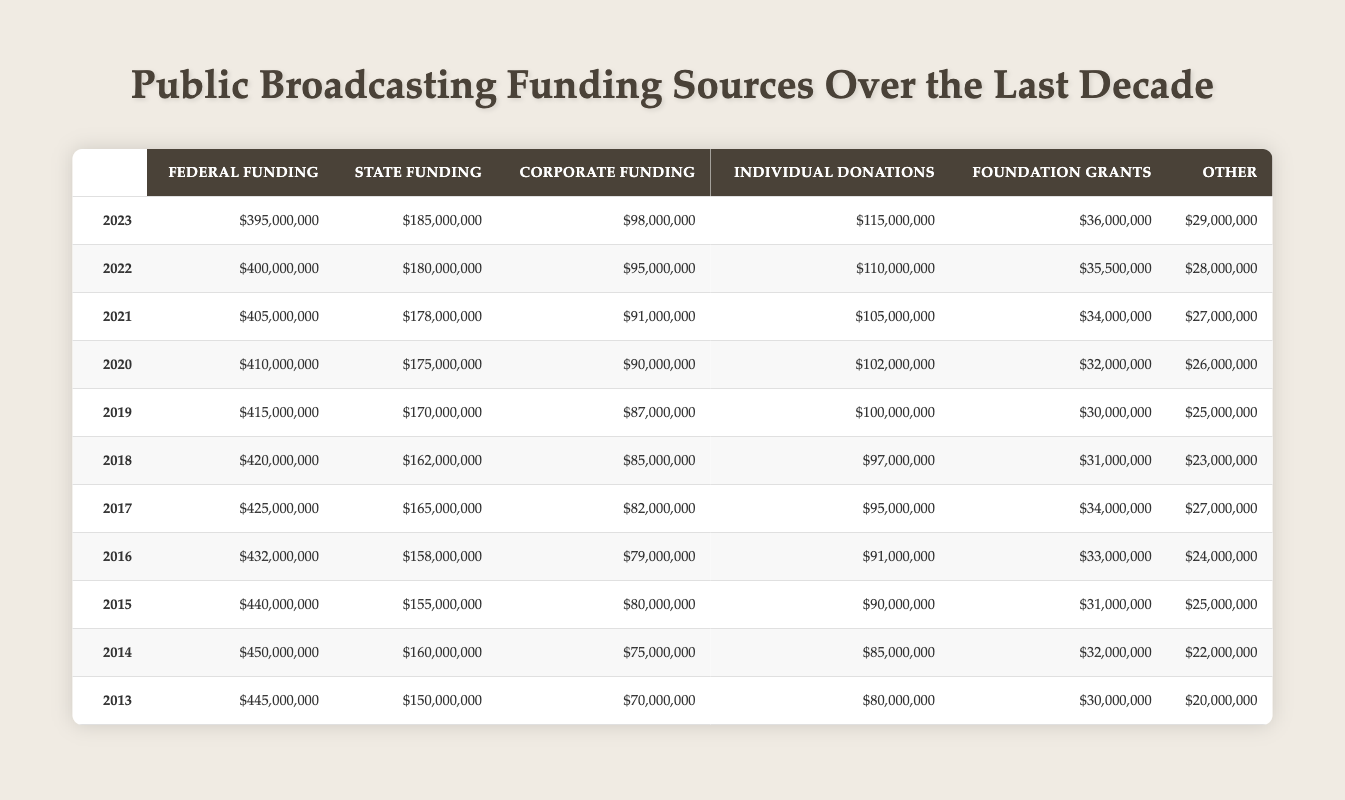What was the total Federal Funding in 2020? The table shows the Federal Funding value for 2020 as $410,000,000.
Answer: $410,000,000 Which year had the highest Individual Donations? The highest value for Individual Donations is in 2023, which is $115,000,000. We can see this value in the 2023 row of the table.
Answer: $115,000,000 In which year did State Funding first exceed $180 million? Looking at the table, State Funding first exceeded $180 million in 2022, which is evident because the value in that year is $180,000,000.
Answer: 2022 What was the increase in Foundation Grants from 2013 to 2023? Foundation Grants in 2013 were $30,000,000, and in 2023 they were $36,000,000. The increase is calculated as $36,000,000 - $30,000,000 = $6,000,000.
Answer: $6,000,000 What was the total Corporate Funding across all years in the table? To find the total Corporate Funding, we sum the Corporate Funding values from all years: $70,000,000 + $75,000,000 + $80,000,000 + $79,000,000 + $82,000,000 + $85,000,000 + $87,000,000 + $90,000,000 + $91,000,000 + $95,000,000 + $98,000,000 = $1,022,000,000.
Answer: $1,022,000,000 Did Federal Funding decrease every year from 2013 to 2023? Checking the values for Federal Funding each year, we can see a consistent decline from $445,000,000 in 2013 to $395,000,000 in 2023, confirming that it decreased every year.
Answer: Yes Which funding source had the most significant increase from 2013 to 2023? Comparing the values, Individual Donations increased from $80,000,000 in 2013 to $115,000,000 in 2023, an increase of $35,000,000. Meanwhile, the next highest increase was Foundation Grants, which went from $30,000,000 to $36,000,000 ($6,000,000). Thus, Individual Donations had the most significant increase.
Answer: Individual Donations What was the average amount of Other funding from 2013 to 2023? To find the average of Other funding, we first sum the values: $20,000,000 + $22,000,000 + $25,000,000 + $24,000,000 + $27,000,000 + $23,000,000 + $25,000,000 + $26,000,000 + $28,000,000 + $29,000,000 = $ 9 1,000,000. Then we divide by the number of years (11). The average is $260,000,000 / 11 = approximately $25,454,545.
Answer: Approximately $25,454,545 What percentage of funding in 2021 came from Federal sources? In 2021, Federal Funding was $405,000,000, and total funding for that year (summing all sources) was $405,000,000 + $178,000,000 + $91,000,000 + $105,000,000 + $34,000,000 + $27,000,000 = $840,000,000. To find the percentage from Federal sources, we calculate ($405,000,000 / $840,000,000) * 100, which equals approximately 48.21%.
Answer: Approximately 48.21% 